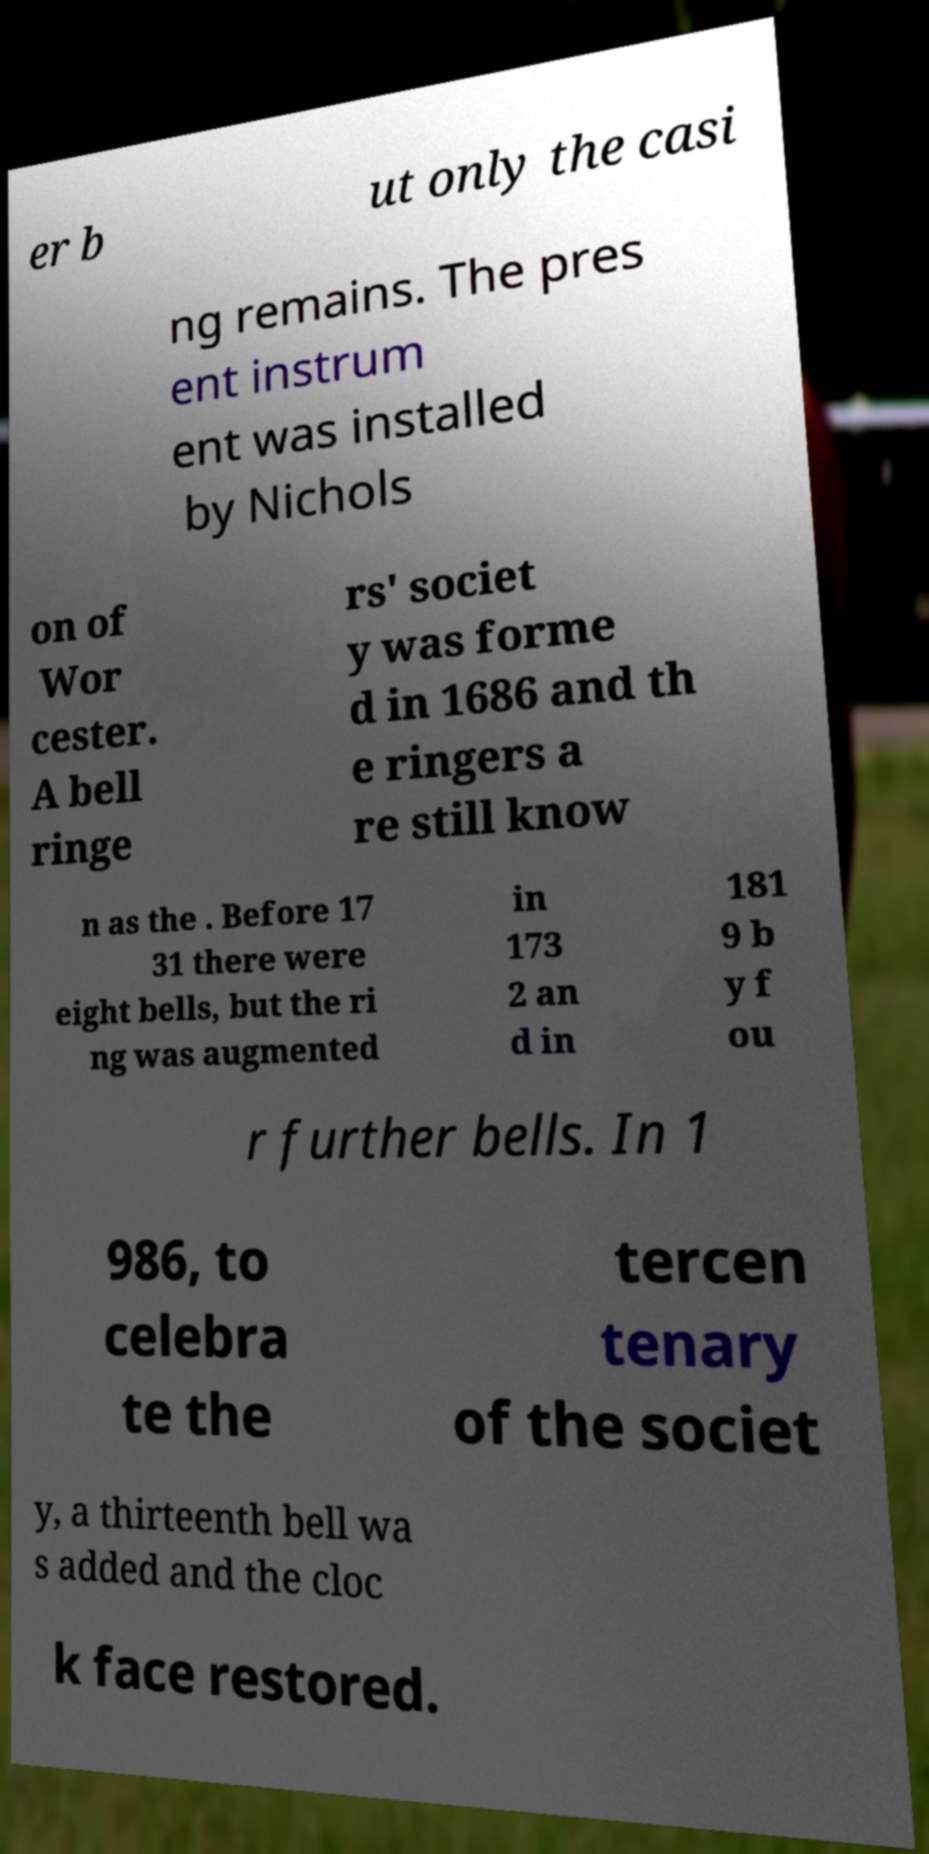Could you extract and type out the text from this image? er b ut only the casi ng remains. The pres ent instrum ent was installed by Nichols on of Wor cester. A bell ringe rs' societ y was forme d in 1686 and th e ringers a re still know n as the . Before 17 31 there were eight bells, but the ri ng was augmented in 173 2 an d in 181 9 b y f ou r further bells. In 1 986, to celebra te the tercen tenary of the societ y, a thirteenth bell wa s added and the cloc k face restored. 